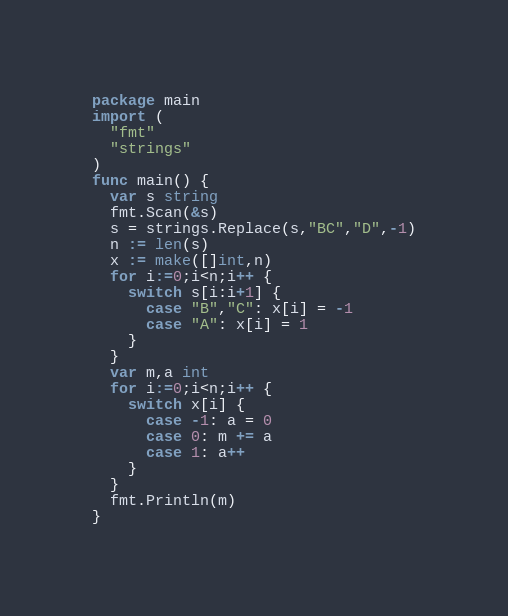Convert code to text. <code><loc_0><loc_0><loc_500><loc_500><_Go_>package main
import (
  "fmt"
  "strings"
)
func main() {
  var s string
  fmt.Scan(&s)
  s = strings.Replace(s,"BC","D",-1)
  n := len(s)
  x := make([]int,n)
  for i:=0;i<n;i++ {
    switch s[i:i+1] {
      case "B","C": x[i] = -1
      case "A": x[i] = 1
    }
  }
  var m,a int
  for i:=0;i<n;i++ {
    switch x[i] {
      case -1: a = 0
      case 0: m += a
      case 1: a++
    }
  }
  fmt.Println(m)
}</code> 